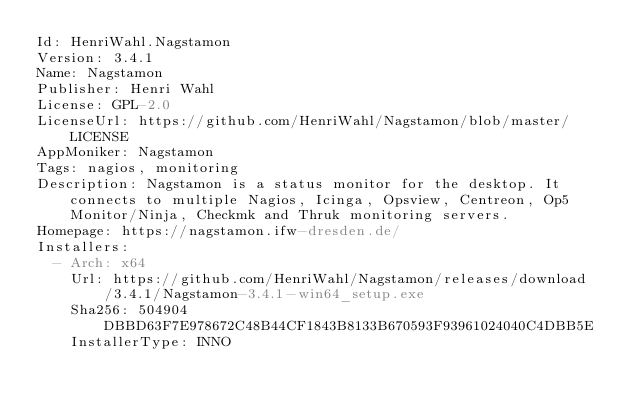Convert code to text. <code><loc_0><loc_0><loc_500><loc_500><_YAML_>Id: HenriWahl.Nagstamon
Version: 3.4.1
Name: Nagstamon
Publisher: Henri Wahl
License: GPL-2.0
LicenseUrl: https://github.com/HenriWahl/Nagstamon/blob/master/LICENSE
AppMoniker: Nagstamon
Tags: nagios, monitoring
Description: Nagstamon is a status monitor for the desktop. It connects to multiple Nagios, Icinga, Opsview, Centreon, Op5 Monitor/Ninja, Checkmk and Thruk monitoring servers.
Homepage: https://nagstamon.ifw-dresden.de/
Installers:
  - Arch: x64
    Url: https://github.com/HenriWahl/Nagstamon/releases/download/3.4.1/Nagstamon-3.4.1-win64_setup.exe
    Sha256: 504904DBBD63F7E978672C48B44CF1843B8133B670593F93961024040C4DBB5E
    InstallerType: INNO</code> 